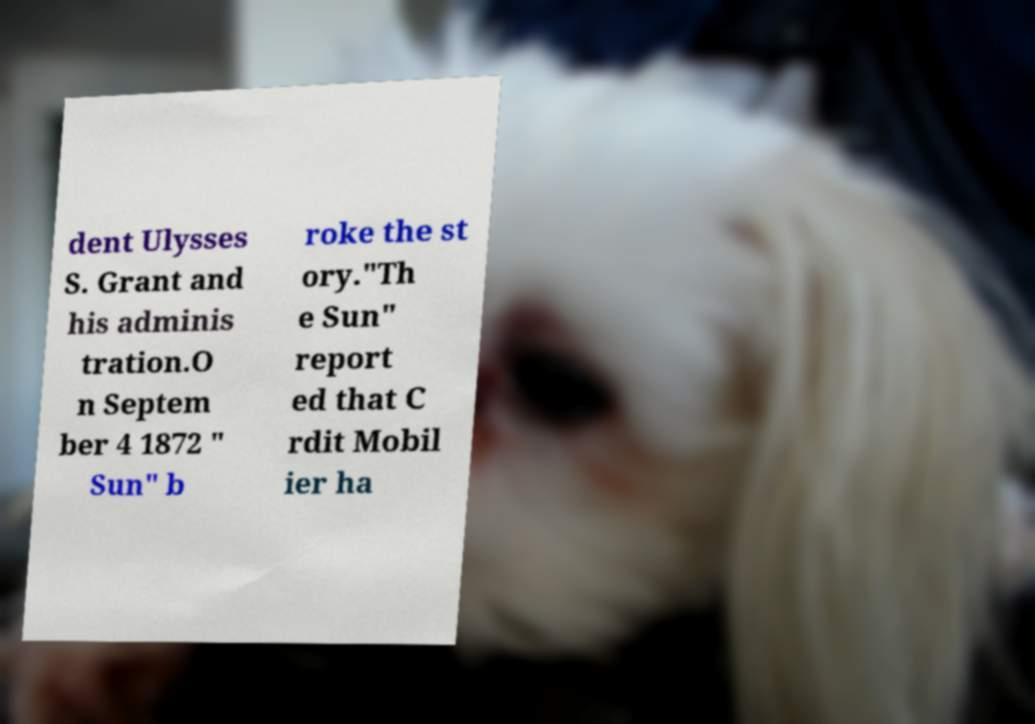Could you assist in decoding the text presented in this image and type it out clearly? dent Ulysses S. Grant and his adminis tration.O n Septem ber 4 1872 " Sun" b roke the st ory."Th e Sun" report ed that C rdit Mobil ier ha 